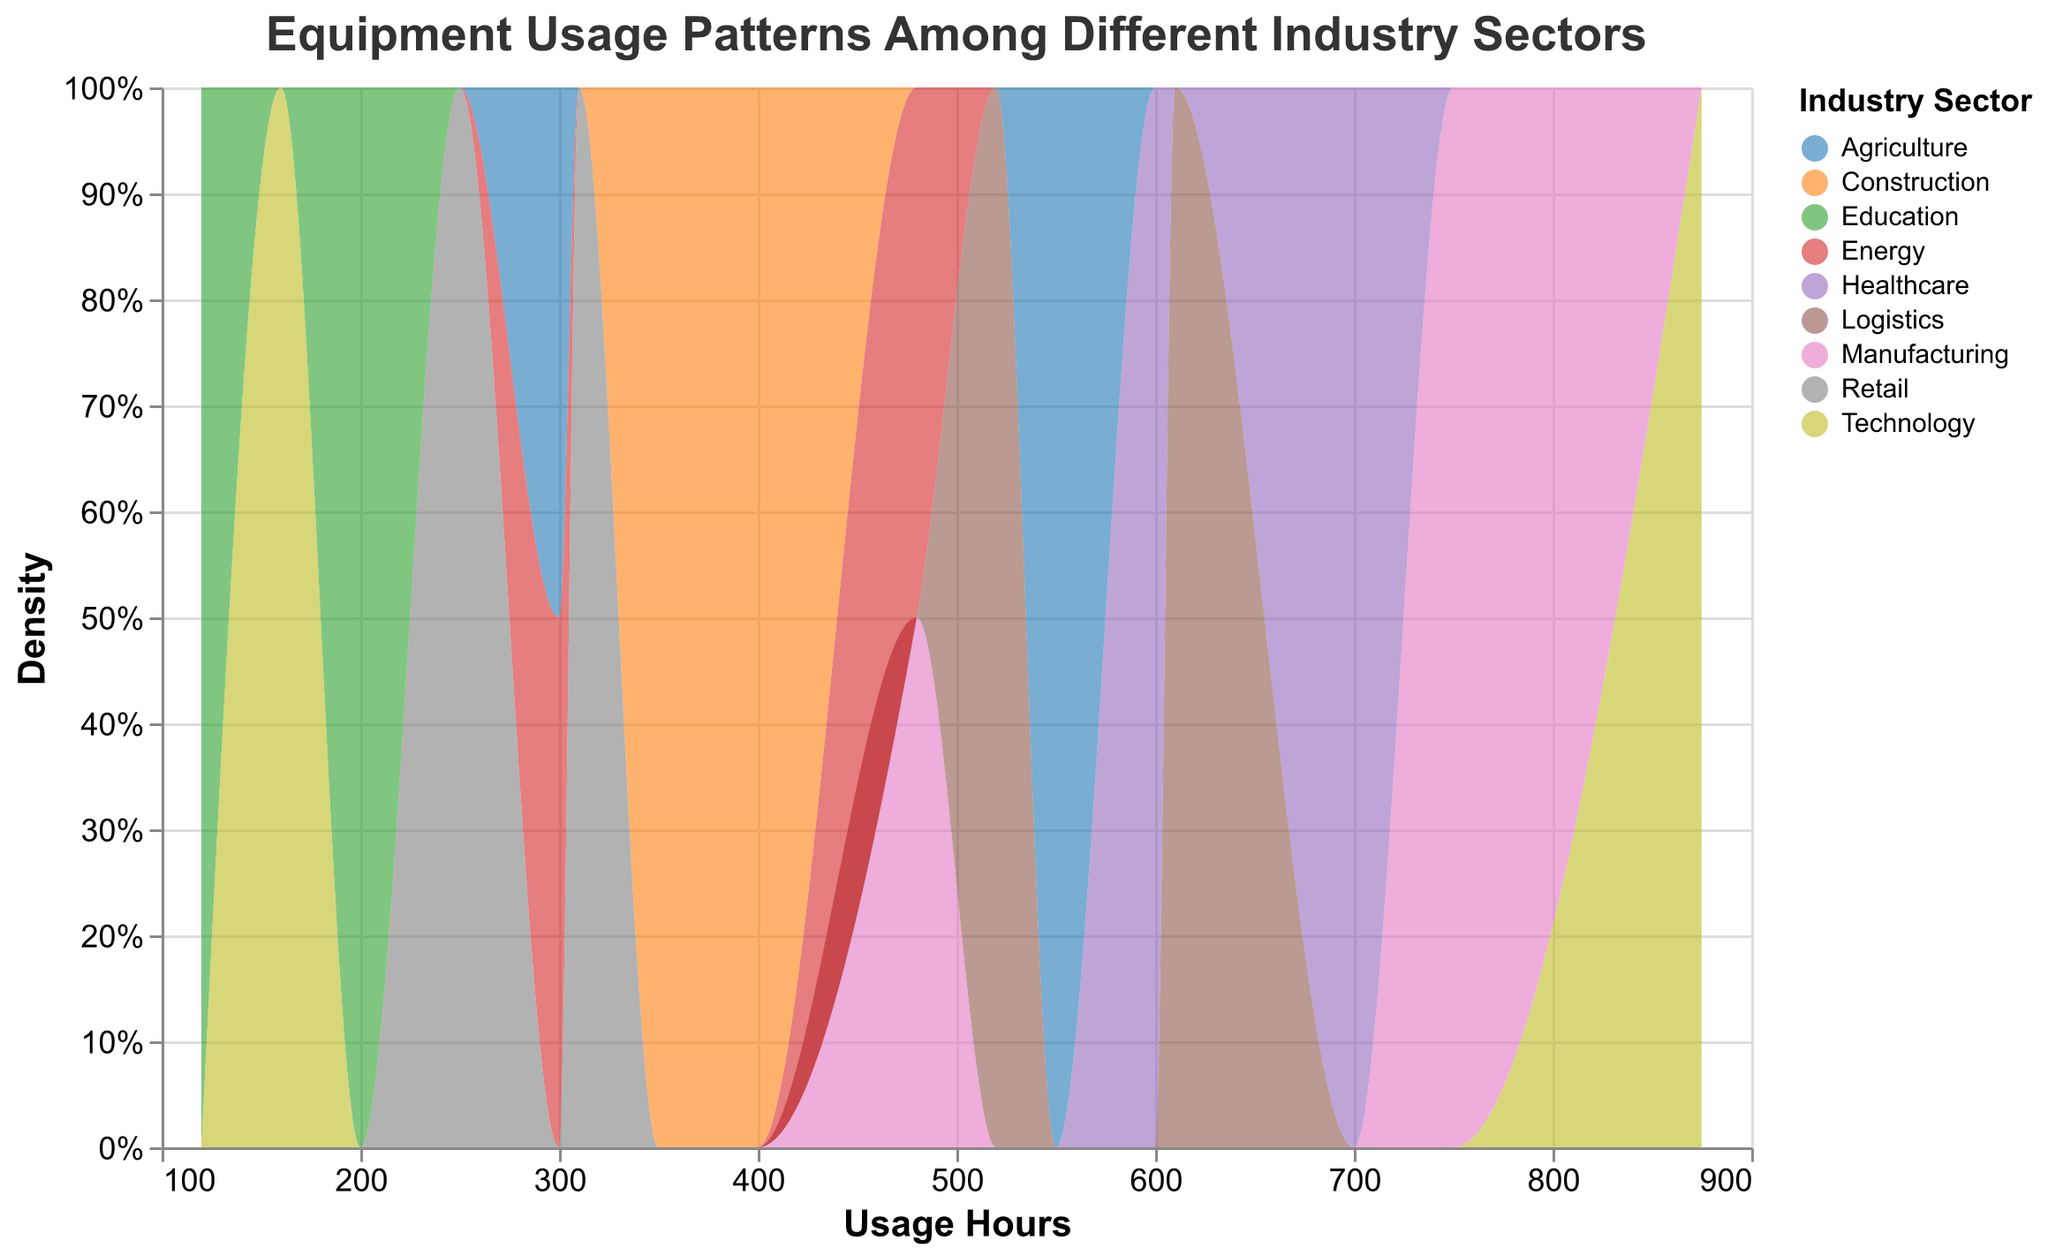What is the title of the plot? The title of the plot is displayed at the top and it reads "Equipment Usage Patterns Among Different Industry Sectors."
Answer: Equipment Usage Patterns Among Different Industry Sectors How many industry sectors are represented in the plot? By inspecting the color legend on the plot, we can see the distinct industry sectors represented. Counting them gives us the total number of sectors.
Answer: 8 Which industry sector has the highest equipment usage hours? From the x-axis on the plot, we observe that "Technology" sector has the highest usage hours with the value reaching 875 for a Server.
Answer: Technology Which equipment in the manufacturing sector has higher usage hours, the 3D Printer or the CNC Machine? By looking at the colors representing "Manufacturing" sector and comparing the x-axis values, the CNC Machine has higher usage hours (750) compared to the 3D Printer (480).
Answer: CNC Machine What is the aggregate count density of the equipment usage hours in the "Healthcare" sector near 650 hours? By examining the peak of the area under the curve, we can see a higher aggregate count density near the x-axis value of 650 for the "Healthcare" sector, visually represented by the color for Healthcare.
Answer: High In which range do most of the equipment usage hours fall for the "Education" sector? Observing the area under the "Education" sector's color on the plot and focusing on the x-axis range, most of the usage hours fall between 100 and 200.
Answer: Between 100 and 200 Compare the usage pattern density of "Logistics" and "Energy" sectors. Which sector demonstrates a higher density peak? By analyzing the plot colors and looking at their respective density curves, "Logistics" shows a higher peak density around the usage hours compared to "Energy."
Answer: Logistics Which sector has the least equipment usage hours, and what is the value? From the plot, the lowest usage hours can be seen at 120 hours for the "Education" sector, specifically for a 3D Printer.
Answer: Education, 120 hours Do usage hours in the "Construction" sector show more spread compared to the "Retail" sector? By examining the spread of the color areas for "Construction" and "Retail" sectors across the x-axis, we can see that "Construction" sector usage hours range more widely (from around 350 to 400) compared to "Retail" (from 250 to 310).
Answer: Yes What is the median value of usage hours in the "Agriculture" sector, considering the given dataset? Considering the data points (550 and 300) for "Agriculture," the median usage hours is calculated by taking the middle value. Since there are two points, the median is the average of 550 and 300, which is (550+300)/2 = 425.
Answer: 425 